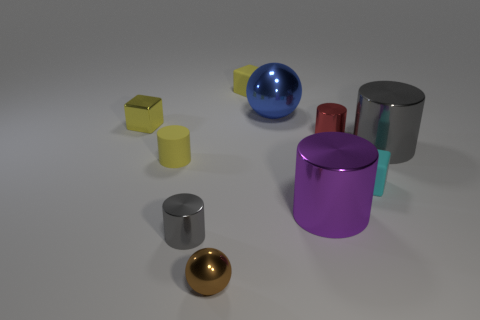Subtract all yellow rubber cylinders. How many cylinders are left? 4 Subtract all red cylinders. How many cylinders are left? 4 Subtract all blue cylinders. Subtract all red blocks. How many cylinders are left? 5 Subtract all cubes. How many objects are left? 7 Subtract all tiny blue rubber cubes. Subtract all tiny gray objects. How many objects are left? 9 Add 9 small balls. How many small balls are left? 10 Add 8 blue balls. How many blue balls exist? 9 Subtract 0 purple balls. How many objects are left? 10 